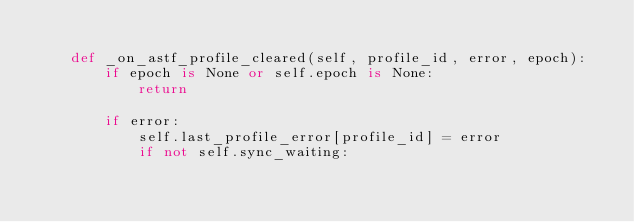Convert code to text. <code><loc_0><loc_0><loc_500><loc_500><_Python_>
    def _on_astf_profile_cleared(self, profile_id, error, epoch):
        if epoch is None or self.epoch is None:
            return

        if error:
            self.last_profile_error[profile_id] = error
            if not self.sync_waiting:</code> 